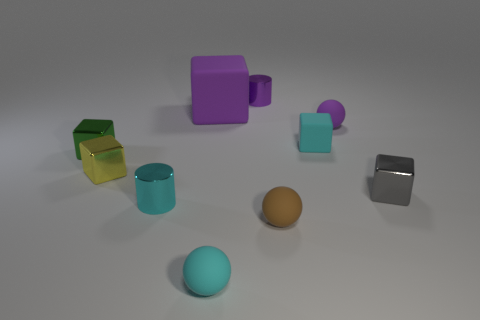Subtract all small gray shiny blocks. How many blocks are left? 4 Subtract all cyan spheres. How many spheres are left? 2 Subtract 4 blocks. How many blocks are left? 1 Subtract all cylinders. How many objects are left? 8 Subtract all big brown metallic objects. Subtract all tiny things. How many objects are left? 1 Add 3 balls. How many balls are left? 6 Add 9 yellow rubber things. How many yellow rubber things exist? 9 Subtract 1 cyan cylinders. How many objects are left? 9 Subtract all yellow cubes. Subtract all brown balls. How many cubes are left? 4 Subtract all red blocks. How many red cylinders are left? 0 